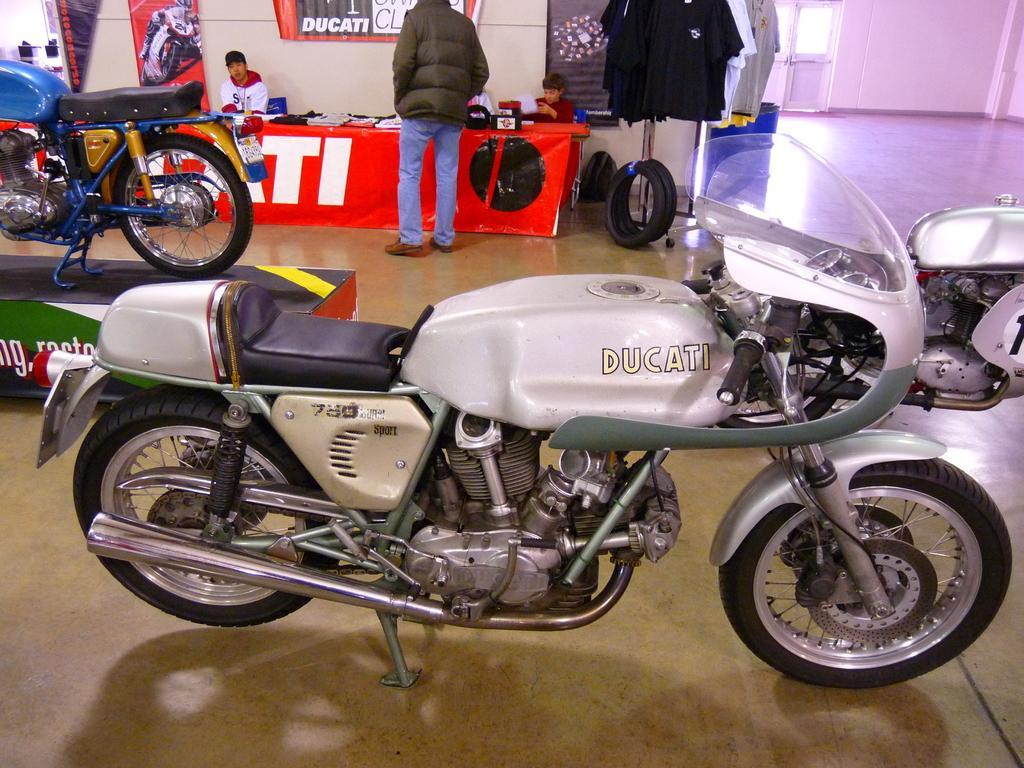Can you describe this image briefly? In this picture we can see likes and box. There are people and we can see objects on the table, clothes hanging on stand, tubes, banners and bag. In the background of the image we can see wall, floor and door. 